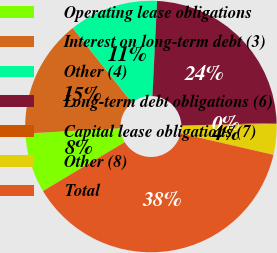<chart> <loc_0><loc_0><loc_500><loc_500><pie_chart><fcel>Operating lease obligations<fcel>Interest on long-term debt (3)<fcel>Other (4)<fcel>Long-term debt obligations (6)<fcel>Capital lease obligations (7)<fcel>Other (8)<fcel>Total<nl><fcel>7.68%<fcel>15.22%<fcel>11.45%<fcel>23.76%<fcel>0.15%<fcel>3.92%<fcel>37.82%<nl></chart> 